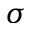Convert formula to latex. <formula><loc_0><loc_0><loc_500><loc_500>\sigma</formula> 